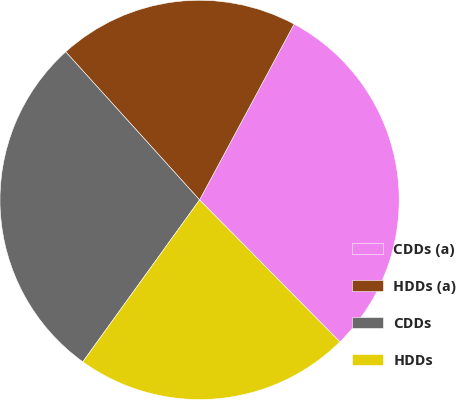<chart> <loc_0><loc_0><loc_500><loc_500><pie_chart><fcel>CDDs (a)<fcel>HDDs (a)<fcel>CDDs<fcel>HDDs<nl><fcel>29.74%<fcel>19.55%<fcel>28.36%<fcel>22.35%<nl></chart> 